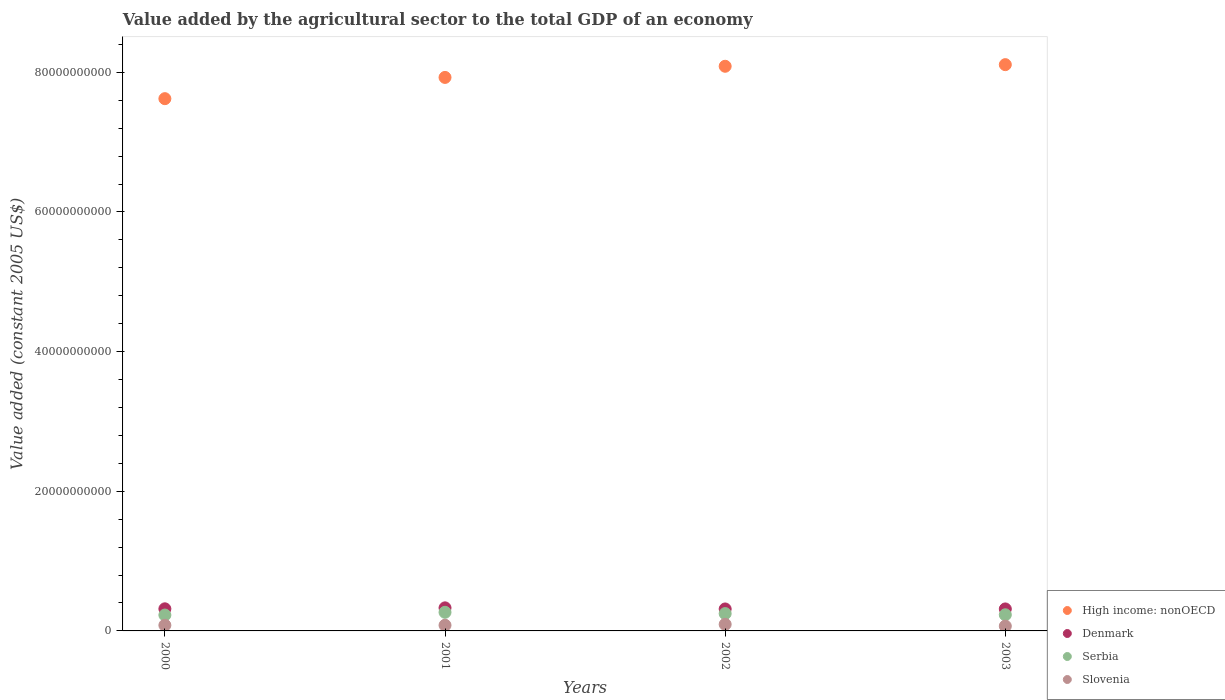Is the number of dotlines equal to the number of legend labels?
Give a very brief answer. Yes. What is the value added by the agricultural sector in Serbia in 2003?
Ensure brevity in your answer.  2.31e+09. Across all years, what is the maximum value added by the agricultural sector in Slovenia?
Provide a short and direct response. 9.40e+08. Across all years, what is the minimum value added by the agricultural sector in High income: nonOECD?
Provide a succinct answer. 7.62e+1. In which year was the value added by the agricultural sector in Slovenia maximum?
Offer a terse response. 2002. In which year was the value added by the agricultural sector in Serbia minimum?
Offer a very short reply. 2000. What is the total value added by the agricultural sector in Denmark in the graph?
Offer a very short reply. 1.28e+1. What is the difference between the value added by the agricultural sector in Slovenia in 2000 and that in 2001?
Offer a very short reply. -2.57e+05. What is the difference between the value added by the agricultural sector in Denmark in 2002 and the value added by the agricultural sector in High income: nonOECD in 2001?
Offer a very short reply. -7.61e+1. What is the average value added by the agricultural sector in Denmark per year?
Offer a very short reply. 3.19e+09. In the year 2003, what is the difference between the value added by the agricultural sector in High income: nonOECD and value added by the agricultural sector in Slovenia?
Keep it short and to the point. 8.04e+1. In how many years, is the value added by the agricultural sector in High income: nonOECD greater than 40000000000 US$?
Provide a short and direct response. 4. What is the ratio of the value added by the agricultural sector in Slovenia in 2001 to that in 2003?
Provide a succinct answer. 1.18. Is the difference between the value added by the agricultural sector in High income: nonOECD in 2000 and 2002 greater than the difference between the value added by the agricultural sector in Slovenia in 2000 and 2002?
Provide a succinct answer. No. What is the difference between the highest and the second highest value added by the agricultural sector in Slovenia?
Your answer should be compact. 1.26e+08. What is the difference between the highest and the lowest value added by the agricultural sector in Slovenia?
Provide a short and direct response. 2.51e+08. In how many years, is the value added by the agricultural sector in Slovenia greater than the average value added by the agricultural sector in Slovenia taken over all years?
Ensure brevity in your answer.  2. Is it the case that in every year, the sum of the value added by the agricultural sector in Serbia and value added by the agricultural sector in Denmark  is greater than the sum of value added by the agricultural sector in High income: nonOECD and value added by the agricultural sector in Slovenia?
Ensure brevity in your answer.  Yes. Does the value added by the agricultural sector in Denmark monotonically increase over the years?
Your answer should be compact. No. Is the value added by the agricultural sector in Serbia strictly greater than the value added by the agricultural sector in High income: nonOECD over the years?
Your response must be concise. No. How many dotlines are there?
Provide a succinct answer. 4. How many years are there in the graph?
Your answer should be compact. 4. Are the values on the major ticks of Y-axis written in scientific E-notation?
Provide a succinct answer. No. Does the graph contain grids?
Your response must be concise. No. Where does the legend appear in the graph?
Ensure brevity in your answer.  Bottom right. How are the legend labels stacked?
Give a very brief answer. Vertical. What is the title of the graph?
Provide a succinct answer. Value added by the agricultural sector to the total GDP of an economy. Does "Macao" appear as one of the legend labels in the graph?
Your answer should be very brief. No. What is the label or title of the Y-axis?
Provide a succinct answer. Value added (constant 2005 US$). What is the Value added (constant 2005 US$) in High income: nonOECD in 2000?
Keep it short and to the point. 7.62e+1. What is the Value added (constant 2005 US$) in Denmark in 2000?
Your answer should be very brief. 3.17e+09. What is the Value added (constant 2005 US$) of Serbia in 2000?
Offer a terse response. 2.27e+09. What is the Value added (constant 2005 US$) in Slovenia in 2000?
Give a very brief answer. 8.14e+08. What is the Value added (constant 2005 US$) in High income: nonOECD in 2001?
Make the answer very short. 7.93e+1. What is the Value added (constant 2005 US$) in Denmark in 2001?
Provide a short and direct response. 3.30e+09. What is the Value added (constant 2005 US$) in Serbia in 2001?
Your response must be concise. 2.67e+09. What is the Value added (constant 2005 US$) in Slovenia in 2001?
Provide a succinct answer. 8.14e+08. What is the Value added (constant 2005 US$) in High income: nonOECD in 2002?
Your answer should be compact. 8.09e+1. What is the Value added (constant 2005 US$) in Denmark in 2002?
Provide a succinct answer. 3.14e+09. What is the Value added (constant 2005 US$) in Serbia in 2002?
Make the answer very short. 2.48e+09. What is the Value added (constant 2005 US$) of Slovenia in 2002?
Keep it short and to the point. 9.40e+08. What is the Value added (constant 2005 US$) in High income: nonOECD in 2003?
Your answer should be very brief. 8.11e+1. What is the Value added (constant 2005 US$) of Denmark in 2003?
Your answer should be very brief. 3.15e+09. What is the Value added (constant 2005 US$) in Serbia in 2003?
Provide a succinct answer. 2.31e+09. What is the Value added (constant 2005 US$) of Slovenia in 2003?
Your answer should be very brief. 6.89e+08. Across all years, what is the maximum Value added (constant 2005 US$) of High income: nonOECD?
Provide a succinct answer. 8.11e+1. Across all years, what is the maximum Value added (constant 2005 US$) in Denmark?
Offer a terse response. 3.30e+09. Across all years, what is the maximum Value added (constant 2005 US$) of Serbia?
Ensure brevity in your answer.  2.67e+09. Across all years, what is the maximum Value added (constant 2005 US$) of Slovenia?
Your answer should be very brief. 9.40e+08. Across all years, what is the minimum Value added (constant 2005 US$) in High income: nonOECD?
Provide a succinct answer. 7.62e+1. Across all years, what is the minimum Value added (constant 2005 US$) in Denmark?
Your response must be concise. 3.14e+09. Across all years, what is the minimum Value added (constant 2005 US$) of Serbia?
Make the answer very short. 2.27e+09. Across all years, what is the minimum Value added (constant 2005 US$) of Slovenia?
Keep it short and to the point. 6.89e+08. What is the total Value added (constant 2005 US$) of High income: nonOECD in the graph?
Ensure brevity in your answer.  3.17e+11. What is the total Value added (constant 2005 US$) in Denmark in the graph?
Make the answer very short. 1.28e+1. What is the total Value added (constant 2005 US$) in Serbia in the graph?
Your response must be concise. 9.74e+09. What is the total Value added (constant 2005 US$) of Slovenia in the graph?
Offer a very short reply. 3.26e+09. What is the difference between the Value added (constant 2005 US$) in High income: nonOECD in 2000 and that in 2001?
Give a very brief answer. -3.04e+09. What is the difference between the Value added (constant 2005 US$) in Denmark in 2000 and that in 2001?
Your response must be concise. -1.37e+08. What is the difference between the Value added (constant 2005 US$) in Serbia in 2000 and that in 2001?
Provide a succinct answer. -3.93e+08. What is the difference between the Value added (constant 2005 US$) in Slovenia in 2000 and that in 2001?
Provide a short and direct response. -2.57e+05. What is the difference between the Value added (constant 2005 US$) of High income: nonOECD in 2000 and that in 2002?
Give a very brief answer. -4.64e+09. What is the difference between the Value added (constant 2005 US$) in Denmark in 2000 and that in 2002?
Keep it short and to the point. 2.18e+07. What is the difference between the Value added (constant 2005 US$) in Serbia in 2000 and that in 2002?
Your response must be concise. -2.10e+08. What is the difference between the Value added (constant 2005 US$) in Slovenia in 2000 and that in 2002?
Keep it short and to the point. -1.26e+08. What is the difference between the Value added (constant 2005 US$) in High income: nonOECD in 2000 and that in 2003?
Your response must be concise. -4.87e+09. What is the difference between the Value added (constant 2005 US$) in Denmark in 2000 and that in 2003?
Offer a very short reply. 1.75e+07. What is the difference between the Value added (constant 2005 US$) in Serbia in 2000 and that in 2003?
Ensure brevity in your answer.  -3.85e+07. What is the difference between the Value added (constant 2005 US$) in Slovenia in 2000 and that in 2003?
Give a very brief answer. 1.25e+08. What is the difference between the Value added (constant 2005 US$) of High income: nonOECD in 2001 and that in 2002?
Ensure brevity in your answer.  -1.60e+09. What is the difference between the Value added (constant 2005 US$) in Denmark in 2001 and that in 2002?
Your response must be concise. 1.59e+08. What is the difference between the Value added (constant 2005 US$) of Serbia in 2001 and that in 2002?
Keep it short and to the point. 1.82e+08. What is the difference between the Value added (constant 2005 US$) in Slovenia in 2001 and that in 2002?
Provide a short and direct response. -1.26e+08. What is the difference between the Value added (constant 2005 US$) in High income: nonOECD in 2001 and that in 2003?
Your answer should be compact. -1.83e+09. What is the difference between the Value added (constant 2005 US$) of Denmark in 2001 and that in 2003?
Provide a succinct answer. 1.55e+08. What is the difference between the Value added (constant 2005 US$) in Serbia in 2001 and that in 2003?
Give a very brief answer. 3.54e+08. What is the difference between the Value added (constant 2005 US$) in Slovenia in 2001 and that in 2003?
Provide a short and direct response. 1.26e+08. What is the difference between the Value added (constant 2005 US$) in High income: nonOECD in 2002 and that in 2003?
Provide a succinct answer. -2.33e+08. What is the difference between the Value added (constant 2005 US$) in Denmark in 2002 and that in 2003?
Your answer should be compact. -4.26e+06. What is the difference between the Value added (constant 2005 US$) in Serbia in 2002 and that in 2003?
Provide a succinct answer. 1.72e+08. What is the difference between the Value added (constant 2005 US$) in Slovenia in 2002 and that in 2003?
Keep it short and to the point. 2.51e+08. What is the difference between the Value added (constant 2005 US$) in High income: nonOECD in 2000 and the Value added (constant 2005 US$) in Denmark in 2001?
Offer a very short reply. 7.29e+1. What is the difference between the Value added (constant 2005 US$) of High income: nonOECD in 2000 and the Value added (constant 2005 US$) of Serbia in 2001?
Offer a terse response. 7.36e+1. What is the difference between the Value added (constant 2005 US$) of High income: nonOECD in 2000 and the Value added (constant 2005 US$) of Slovenia in 2001?
Make the answer very short. 7.54e+1. What is the difference between the Value added (constant 2005 US$) of Denmark in 2000 and the Value added (constant 2005 US$) of Serbia in 2001?
Keep it short and to the point. 5.00e+08. What is the difference between the Value added (constant 2005 US$) in Denmark in 2000 and the Value added (constant 2005 US$) in Slovenia in 2001?
Provide a succinct answer. 2.35e+09. What is the difference between the Value added (constant 2005 US$) in Serbia in 2000 and the Value added (constant 2005 US$) in Slovenia in 2001?
Your answer should be compact. 1.46e+09. What is the difference between the Value added (constant 2005 US$) of High income: nonOECD in 2000 and the Value added (constant 2005 US$) of Denmark in 2002?
Make the answer very short. 7.31e+1. What is the difference between the Value added (constant 2005 US$) in High income: nonOECD in 2000 and the Value added (constant 2005 US$) in Serbia in 2002?
Offer a very short reply. 7.37e+1. What is the difference between the Value added (constant 2005 US$) of High income: nonOECD in 2000 and the Value added (constant 2005 US$) of Slovenia in 2002?
Offer a very short reply. 7.53e+1. What is the difference between the Value added (constant 2005 US$) of Denmark in 2000 and the Value added (constant 2005 US$) of Serbia in 2002?
Make the answer very short. 6.82e+08. What is the difference between the Value added (constant 2005 US$) of Denmark in 2000 and the Value added (constant 2005 US$) of Slovenia in 2002?
Provide a succinct answer. 2.23e+09. What is the difference between the Value added (constant 2005 US$) of Serbia in 2000 and the Value added (constant 2005 US$) of Slovenia in 2002?
Provide a succinct answer. 1.33e+09. What is the difference between the Value added (constant 2005 US$) in High income: nonOECD in 2000 and the Value added (constant 2005 US$) in Denmark in 2003?
Ensure brevity in your answer.  7.31e+1. What is the difference between the Value added (constant 2005 US$) in High income: nonOECD in 2000 and the Value added (constant 2005 US$) in Serbia in 2003?
Provide a short and direct response. 7.39e+1. What is the difference between the Value added (constant 2005 US$) in High income: nonOECD in 2000 and the Value added (constant 2005 US$) in Slovenia in 2003?
Your answer should be compact. 7.55e+1. What is the difference between the Value added (constant 2005 US$) of Denmark in 2000 and the Value added (constant 2005 US$) of Serbia in 2003?
Give a very brief answer. 8.54e+08. What is the difference between the Value added (constant 2005 US$) in Denmark in 2000 and the Value added (constant 2005 US$) in Slovenia in 2003?
Ensure brevity in your answer.  2.48e+09. What is the difference between the Value added (constant 2005 US$) of Serbia in 2000 and the Value added (constant 2005 US$) of Slovenia in 2003?
Keep it short and to the point. 1.58e+09. What is the difference between the Value added (constant 2005 US$) in High income: nonOECD in 2001 and the Value added (constant 2005 US$) in Denmark in 2002?
Give a very brief answer. 7.61e+1. What is the difference between the Value added (constant 2005 US$) in High income: nonOECD in 2001 and the Value added (constant 2005 US$) in Serbia in 2002?
Offer a very short reply. 7.68e+1. What is the difference between the Value added (constant 2005 US$) in High income: nonOECD in 2001 and the Value added (constant 2005 US$) in Slovenia in 2002?
Your answer should be compact. 7.83e+1. What is the difference between the Value added (constant 2005 US$) in Denmark in 2001 and the Value added (constant 2005 US$) in Serbia in 2002?
Your answer should be very brief. 8.20e+08. What is the difference between the Value added (constant 2005 US$) in Denmark in 2001 and the Value added (constant 2005 US$) in Slovenia in 2002?
Your answer should be very brief. 2.36e+09. What is the difference between the Value added (constant 2005 US$) in Serbia in 2001 and the Value added (constant 2005 US$) in Slovenia in 2002?
Keep it short and to the point. 1.73e+09. What is the difference between the Value added (constant 2005 US$) of High income: nonOECD in 2001 and the Value added (constant 2005 US$) of Denmark in 2003?
Make the answer very short. 7.61e+1. What is the difference between the Value added (constant 2005 US$) of High income: nonOECD in 2001 and the Value added (constant 2005 US$) of Serbia in 2003?
Your answer should be very brief. 7.70e+1. What is the difference between the Value added (constant 2005 US$) of High income: nonOECD in 2001 and the Value added (constant 2005 US$) of Slovenia in 2003?
Keep it short and to the point. 7.86e+1. What is the difference between the Value added (constant 2005 US$) of Denmark in 2001 and the Value added (constant 2005 US$) of Serbia in 2003?
Give a very brief answer. 9.91e+08. What is the difference between the Value added (constant 2005 US$) of Denmark in 2001 and the Value added (constant 2005 US$) of Slovenia in 2003?
Make the answer very short. 2.61e+09. What is the difference between the Value added (constant 2005 US$) in Serbia in 2001 and the Value added (constant 2005 US$) in Slovenia in 2003?
Provide a succinct answer. 1.98e+09. What is the difference between the Value added (constant 2005 US$) of High income: nonOECD in 2002 and the Value added (constant 2005 US$) of Denmark in 2003?
Ensure brevity in your answer.  7.77e+1. What is the difference between the Value added (constant 2005 US$) in High income: nonOECD in 2002 and the Value added (constant 2005 US$) in Serbia in 2003?
Offer a very short reply. 7.86e+1. What is the difference between the Value added (constant 2005 US$) of High income: nonOECD in 2002 and the Value added (constant 2005 US$) of Slovenia in 2003?
Your response must be concise. 8.02e+1. What is the difference between the Value added (constant 2005 US$) of Denmark in 2002 and the Value added (constant 2005 US$) of Serbia in 2003?
Offer a terse response. 8.32e+08. What is the difference between the Value added (constant 2005 US$) in Denmark in 2002 and the Value added (constant 2005 US$) in Slovenia in 2003?
Offer a terse response. 2.46e+09. What is the difference between the Value added (constant 2005 US$) in Serbia in 2002 and the Value added (constant 2005 US$) in Slovenia in 2003?
Keep it short and to the point. 1.80e+09. What is the average Value added (constant 2005 US$) in High income: nonOECD per year?
Your answer should be very brief. 7.94e+1. What is the average Value added (constant 2005 US$) of Denmark per year?
Provide a succinct answer. 3.19e+09. What is the average Value added (constant 2005 US$) in Serbia per year?
Offer a very short reply. 2.43e+09. What is the average Value added (constant 2005 US$) of Slovenia per year?
Ensure brevity in your answer.  8.14e+08. In the year 2000, what is the difference between the Value added (constant 2005 US$) in High income: nonOECD and Value added (constant 2005 US$) in Denmark?
Your answer should be very brief. 7.31e+1. In the year 2000, what is the difference between the Value added (constant 2005 US$) in High income: nonOECD and Value added (constant 2005 US$) in Serbia?
Your answer should be compact. 7.40e+1. In the year 2000, what is the difference between the Value added (constant 2005 US$) in High income: nonOECD and Value added (constant 2005 US$) in Slovenia?
Your answer should be very brief. 7.54e+1. In the year 2000, what is the difference between the Value added (constant 2005 US$) in Denmark and Value added (constant 2005 US$) in Serbia?
Provide a succinct answer. 8.93e+08. In the year 2000, what is the difference between the Value added (constant 2005 US$) in Denmark and Value added (constant 2005 US$) in Slovenia?
Ensure brevity in your answer.  2.35e+09. In the year 2000, what is the difference between the Value added (constant 2005 US$) of Serbia and Value added (constant 2005 US$) of Slovenia?
Make the answer very short. 1.46e+09. In the year 2001, what is the difference between the Value added (constant 2005 US$) in High income: nonOECD and Value added (constant 2005 US$) in Denmark?
Your answer should be very brief. 7.60e+1. In the year 2001, what is the difference between the Value added (constant 2005 US$) in High income: nonOECD and Value added (constant 2005 US$) in Serbia?
Your answer should be very brief. 7.66e+1. In the year 2001, what is the difference between the Value added (constant 2005 US$) in High income: nonOECD and Value added (constant 2005 US$) in Slovenia?
Provide a short and direct response. 7.85e+1. In the year 2001, what is the difference between the Value added (constant 2005 US$) of Denmark and Value added (constant 2005 US$) of Serbia?
Your response must be concise. 6.37e+08. In the year 2001, what is the difference between the Value added (constant 2005 US$) of Denmark and Value added (constant 2005 US$) of Slovenia?
Ensure brevity in your answer.  2.49e+09. In the year 2001, what is the difference between the Value added (constant 2005 US$) of Serbia and Value added (constant 2005 US$) of Slovenia?
Offer a very short reply. 1.85e+09. In the year 2002, what is the difference between the Value added (constant 2005 US$) of High income: nonOECD and Value added (constant 2005 US$) of Denmark?
Ensure brevity in your answer.  7.77e+1. In the year 2002, what is the difference between the Value added (constant 2005 US$) in High income: nonOECD and Value added (constant 2005 US$) in Serbia?
Your answer should be very brief. 7.84e+1. In the year 2002, what is the difference between the Value added (constant 2005 US$) of High income: nonOECD and Value added (constant 2005 US$) of Slovenia?
Provide a succinct answer. 7.99e+1. In the year 2002, what is the difference between the Value added (constant 2005 US$) in Denmark and Value added (constant 2005 US$) in Serbia?
Make the answer very short. 6.61e+08. In the year 2002, what is the difference between the Value added (constant 2005 US$) of Denmark and Value added (constant 2005 US$) of Slovenia?
Give a very brief answer. 2.20e+09. In the year 2002, what is the difference between the Value added (constant 2005 US$) in Serbia and Value added (constant 2005 US$) in Slovenia?
Ensure brevity in your answer.  1.54e+09. In the year 2003, what is the difference between the Value added (constant 2005 US$) of High income: nonOECD and Value added (constant 2005 US$) of Denmark?
Your answer should be very brief. 7.80e+1. In the year 2003, what is the difference between the Value added (constant 2005 US$) of High income: nonOECD and Value added (constant 2005 US$) of Serbia?
Your answer should be very brief. 7.88e+1. In the year 2003, what is the difference between the Value added (constant 2005 US$) in High income: nonOECD and Value added (constant 2005 US$) in Slovenia?
Offer a very short reply. 8.04e+1. In the year 2003, what is the difference between the Value added (constant 2005 US$) of Denmark and Value added (constant 2005 US$) of Serbia?
Your response must be concise. 8.37e+08. In the year 2003, what is the difference between the Value added (constant 2005 US$) in Denmark and Value added (constant 2005 US$) in Slovenia?
Your answer should be compact. 2.46e+09. In the year 2003, what is the difference between the Value added (constant 2005 US$) of Serbia and Value added (constant 2005 US$) of Slovenia?
Provide a short and direct response. 1.62e+09. What is the ratio of the Value added (constant 2005 US$) of High income: nonOECD in 2000 to that in 2001?
Offer a terse response. 0.96. What is the ratio of the Value added (constant 2005 US$) in Denmark in 2000 to that in 2001?
Keep it short and to the point. 0.96. What is the ratio of the Value added (constant 2005 US$) in Serbia in 2000 to that in 2001?
Give a very brief answer. 0.85. What is the ratio of the Value added (constant 2005 US$) of Slovenia in 2000 to that in 2001?
Your response must be concise. 1. What is the ratio of the Value added (constant 2005 US$) of High income: nonOECD in 2000 to that in 2002?
Your response must be concise. 0.94. What is the ratio of the Value added (constant 2005 US$) of Denmark in 2000 to that in 2002?
Your answer should be very brief. 1.01. What is the ratio of the Value added (constant 2005 US$) of Serbia in 2000 to that in 2002?
Your answer should be compact. 0.92. What is the ratio of the Value added (constant 2005 US$) of Slovenia in 2000 to that in 2002?
Ensure brevity in your answer.  0.87. What is the ratio of the Value added (constant 2005 US$) in High income: nonOECD in 2000 to that in 2003?
Provide a short and direct response. 0.94. What is the ratio of the Value added (constant 2005 US$) in Denmark in 2000 to that in 2003?
Provide a short and direct response. 1.01. What is the ratio of the Value added (constant 2005 US$) in Serbia in 2000 to that in 2003?
Give a very brief answer. 0.98. What is the ratio of the Value added (constant 2005 US$) in Slovenia in 2000 to that in 2003?
Keep it short and to the point. 1.18. What is the ratio of the Value added (constant 2005 US$) of High income: nonOECD in 2001 to that in 2002?
Make the answer very short. 0.98. What is the ratio of the Value added (constant 2005 US$) in Denmark in 2001 to that in 2002?
Your response must be concise. 1.05. What is the ratio of the Value added (constant 2005 US$) of Serbia in 2001 to that in 2002?
Give a very brief answer. 1.07. What is the ratio of the Value added (constant 2005 US$) in Slovenia in 2001 to that in 2002?
Your answer should be compact. 0.87. What is the ratio of the Value added (constant 2005 US$) in High income: nonOECD in 2001 to that in 2003?
Provide a succinct answer. 0.98. What is the ratio of the Value added (constant 2005 US$) in Denmark in 2001 to that in 2003?
Ensure brevity in your answer.  1.05. What is the ratio of the Value added (constant 2005 US$) in Serbia in 2001 to that in 2003?
Your response must be concise. 1.15. What is the ratio of the Value added (constant 2005 US$) in Slovenia in 2001 to that in 2003?
Ensure brevity in your answer.  1.18. What is the ratio of the Value added (constant 2005 US$) of Denmark in 2002 to that in 2003?
Offer a terse response. 1. What is the ratio of the Value added (constant 2005 US$) in Serbia in 2002 to that in 2003?
Keep it short and to the point. 1.07. What is the ratio of the Value added (constant 2005 US$) in Slovenia in 2002 to that in 2003?
Make the answer very short. 1.36. What is the difference between the highest and the second highest Value added (constant 2005 US$) in High income: nonOECD?
Your answer should be compact. 2.33e+08. What is the difference between the highest and the second highest Value added (constant 2005 US$) in Denmark?
Your answer should be very brief. 1.37e+08. What is the difference between the highest and the second highest Value added (constant 2005 US$) in Serbia?
Provide a short and direct response. 1.82e+08. What is the difference between the highest and the second highest Value added (constant 2005 US$) in Slovenia?
Provide a short and direct response. 1.26e+08. What is the difference between the highest and the lowest Value added (constant 2005 US$) in High income: nonOECD?
Your answer should be compact. 4.87e+09. What is the difference between the highest and the lowest Value added (constant 2005 US$) in Denmark?
Offer a very short reply. 1.59e+08. What is the difference between the highest and the lowest Value added (constant 2005 US$) of Serbia?
Make the answer very short. 3.93e+08. What is the difference between the highest and the lowest Value added (constant 2005 US$) in Slovenia?
Provide a succinct answer. 2.51e+08. 